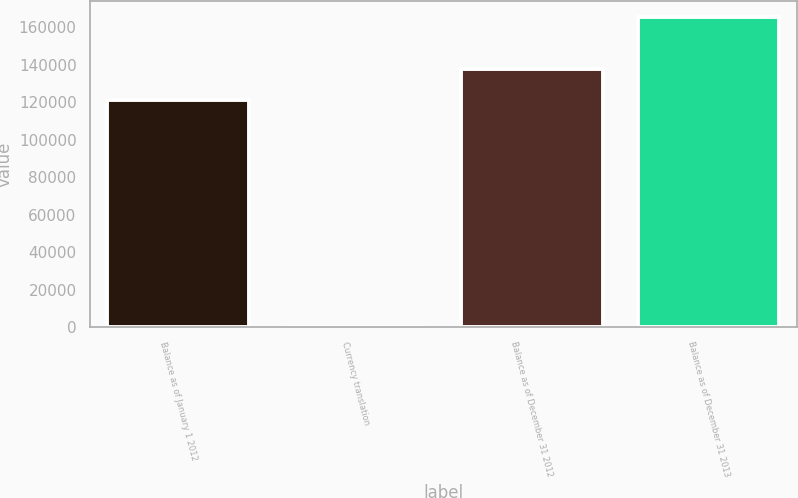<chart> <loc_0><loc_0><loc_500><loc_500><bar_chart><fcel>Balance as of January 1 2012<fcel>Currency translation<fcel>Balance as of December 31 2012<fcel>Balance as of December 31 2013<nl><fcel>121244<fcel>162<fcel>137781<fcel>165532<nl></chart> 